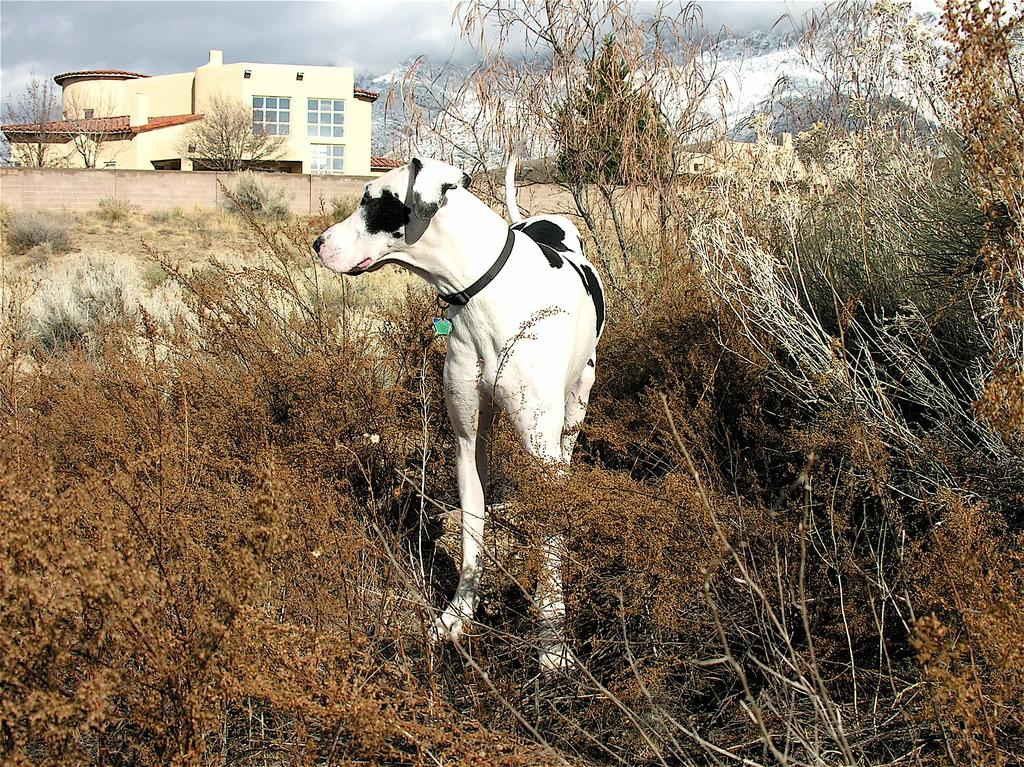What animal is present in the image? There is a dog standing on the ground in the image. What type of vegetation can be seen in the image? There are bare plants and trees in the image. What can be seen in the background of the image? There are bare trees, buildings, a mountain, a wall, and clouds in the sky in the background. What type of test is being conducted on the dog in the image? There is no test being conducted on the dog in the image; it is simply standing on the ground. 